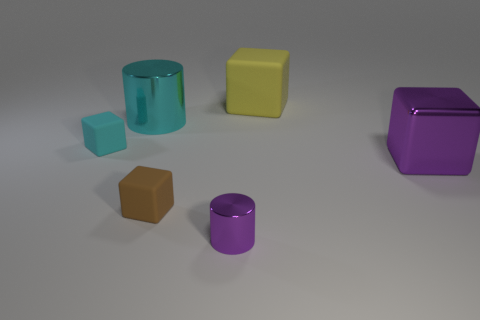Subtract 1 cubes. How many cubes are left? 3 Subtract all cyan cylinders. Subtract all gray blocks. How many cylinders are left? 1 Add 4 tiny purple rubber spheres. How many objects exist? 10 Subtract all cubes. How many objects are left? 2 Add 1 cylinders. How many cylinders exist? 3 Subtract 1 purple blocks. How many objects are left? 5 Subtract all purple spheres. Subtract all tiny rubber blocks. How many objects are left? 4 Add 3 small purple cylinders. How many small purple cylinders are left? 4 